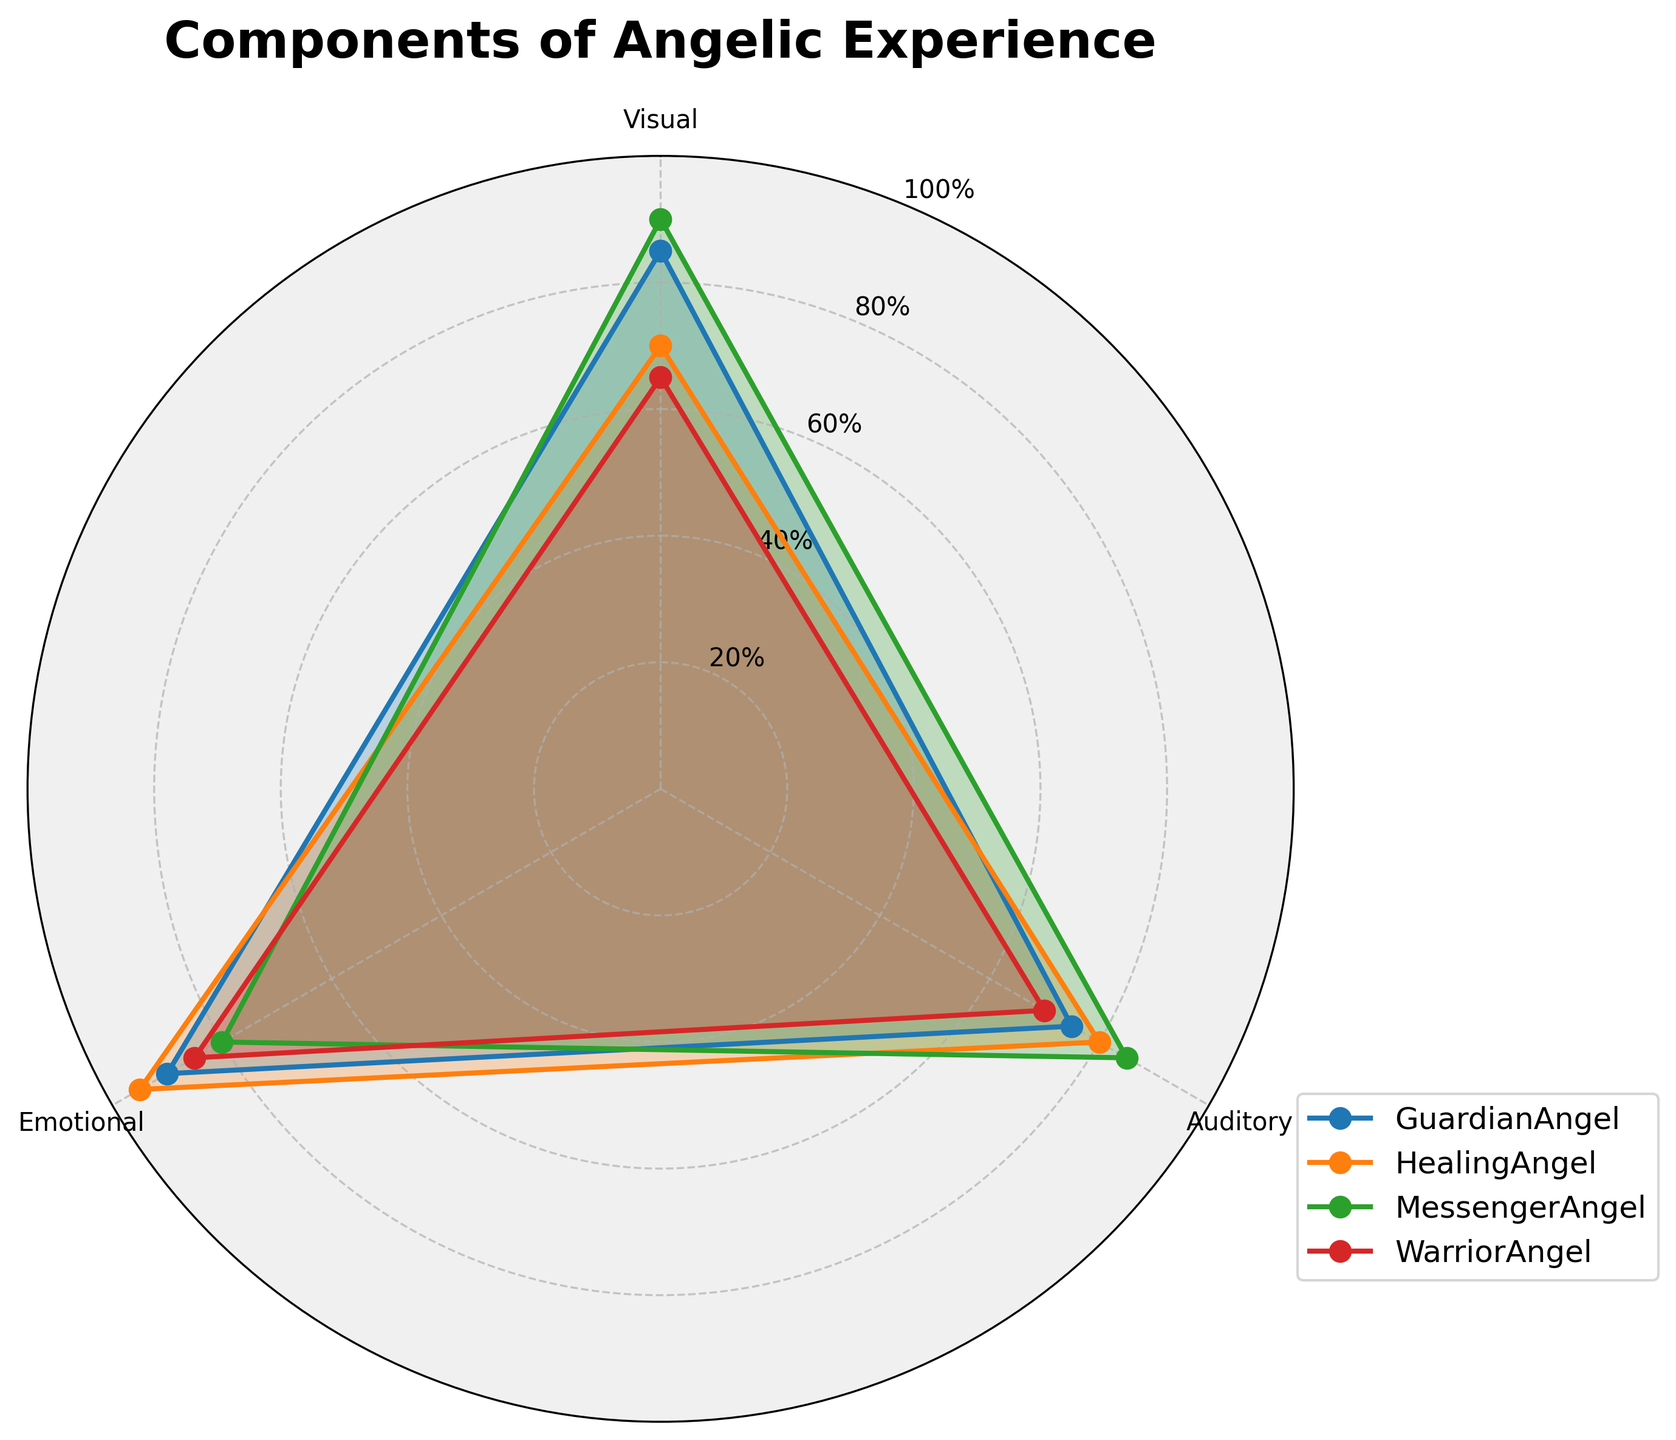What's the title of the radar chart? The title is prominently displayed at the top of the chart. It reads, "Components of Angelic Experience"
Answer: Components of Angelic Experience How many groups of angels are compared in the radar chart? By counting the number of distinct segments or colored areas in the chart, we can see that there are four groups of angels represented.
Answer: Four Which group has the highest Emotional score? By examining the chart, we can see that the group with the highest point along the Emotional axis is the HealingAngel.
Answer: HealingAngel What are the three components measured in this radar chart? The radar chart has three labeled axes which correspond to the components being measured. These are Visual, Auditory, and Emotional.
Answer: Visual, Auditory, Emotional Which angelic group has the lowest Visual score? From the chart, we can observe that the WarriorAngel has the lowest point on the Visual axis.
Answer: WarriorAngel What is the average score of the MessengerAngel group across all components? To find the average score, we add up the scores for Visual (90), Auditory (85), and Emotional (80), and then divide by three. (90+85+80)/3 = 255/3 = 85
Answer: 85 Is the Auditory score of the HealingAngel higher than the Visual score of the GuardianAngel? By comparing the points on the chart, we see the Auditory score of the HealingAngel is 80, while the Visual score of the GuardianAngel is 85. Since 80 < 85, the Auditory score of the HealingAngel is not higher.
Answer: No Which group shows the greatest balance across all three components? To determine balance, we look for a group where the scores for Visual, Auditory, and Emotional are closest to one another. MessengerAngel has scores of Visual (90), Auditory (85), and Emotional (80), which shows the least variation.
Answer: MessengerAngel What is the difference between the highest and lowest Emotional scores observed? The highest Emotional score is for HealingAngel (95), and the lowest is for MessengerAngel (80). The difference is 95 - 80 = 15.
Answer: 15 Which group has a greater Visual score, WarriorAngel or HealingAngel? By comparing the points on the Visual axis, we see the WarriorAngel has a score of 65, while the HealingAngel has a score of 70. Since 70 > 65, the HealingAngel has a greater Visual score.
Answer: HealingAngel 